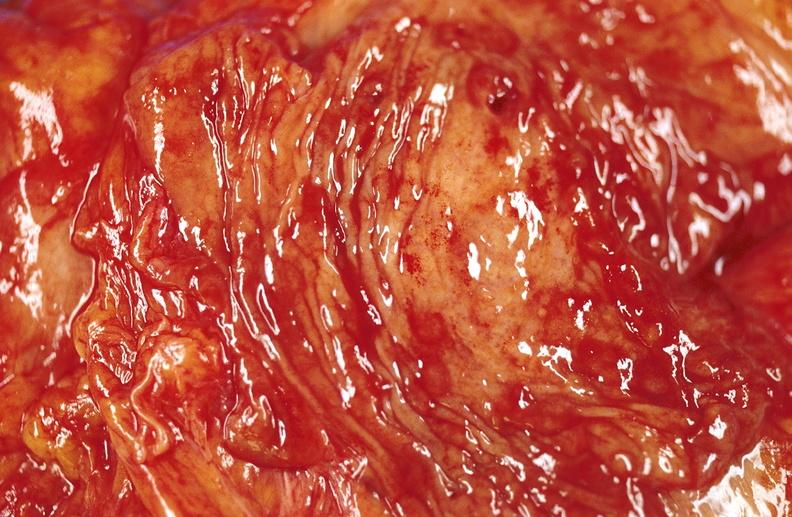what is present?
Answer the question using a single word or phrase. Gastrointestinal 